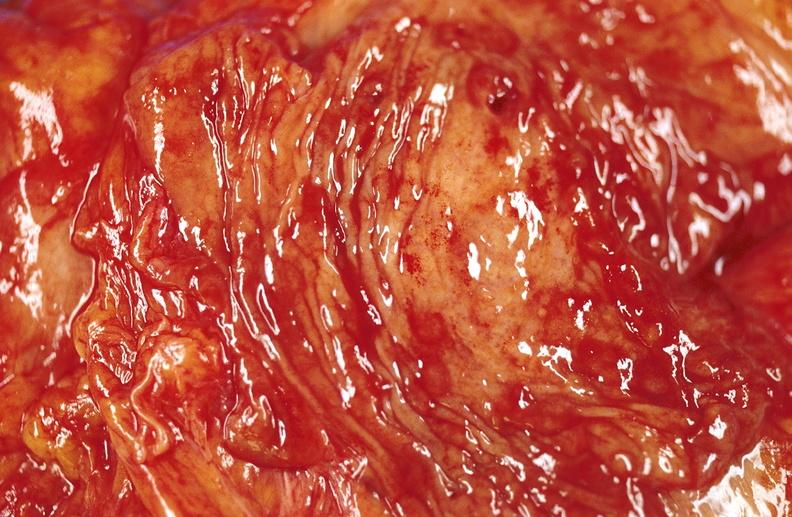what is present?
Answer the question using a single word or phrase. Gastrointestinal 